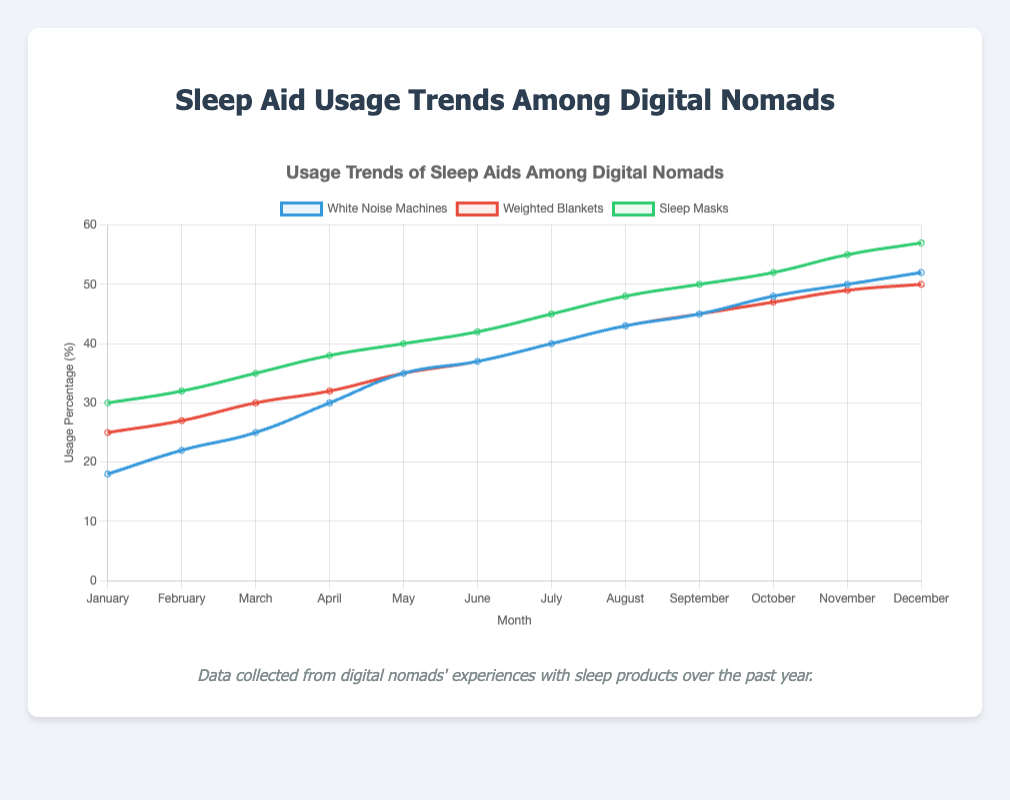What month shows the highest usage of sleep masks? To find the highest usage month for sleep masks, look at the curve representing sleep masks and identify the peak value. The peak value is 57, which corresponds to December.
Answer: December How did the usage of weighted blankets change from January to December? Compare the values for weighted blankets in January and December. In January, it was 25, and in December, it was 50. The change is an increase of 25 units.
Answer: Increased by 25 units Which sleep aid showed the fastest growth between July and August? Compare the difference in usage for each sleep aid between July and August. The differences are: White Noise Machines (3 units), Weighted Blankets (3 units), Sleep Masks (3 units). Since all differences are equal, no sleep aid grew faster than the others.
Answer: No difference During which month are the usage rates of white noise machines and weighted blankets equal? Look for the month where the values for white noise machines and weighted blankets are the same. In September, both have a value of 45.
Answer: September What is the average usage of sleep masks for the first half of the year (January to June)? Sum the values from January to June for sleep masks: 30 + 32 + 35 + 38 + 40 + 42 = 217, then divide by 6: 217 / 6 ≈ 36.17.
Answer: 36.17 Has the usage of white noise machines always been lower than sleep masks throughout the year? Compare the white noise machines and sleep masks curves across all months. In every month, the usage of sleep masks is higher than white noise machines.
Answer: Yes How much did the usage of white noise machines increase from March to November? Find the values for white noise machines in March and November: 25 and 50 respectively. Calculate the increase: 50 - 25 = 25.
Answer: Increased by 25 units What trend do you observe for the usage of sleep aids in the latter half of the year? From July to December, observe all three curves. White noise machines, weighted blankets, and sleep masks all increase steadily over these months.
Answer: Steady increase Which month saw the least usage for white noise machines? Identify the month with the lowest value for white noise machines. In January, the value is lowest at 18.
Answer: January What is the rate of increase for weighted blankets from March to April? Find the values for weighted blankets in March and April: 30 and 32 respectively. Calculate the rate of increase: (32 - 30) / 30 * 100% ≈ 6.67%.
Answer: 6.67% 